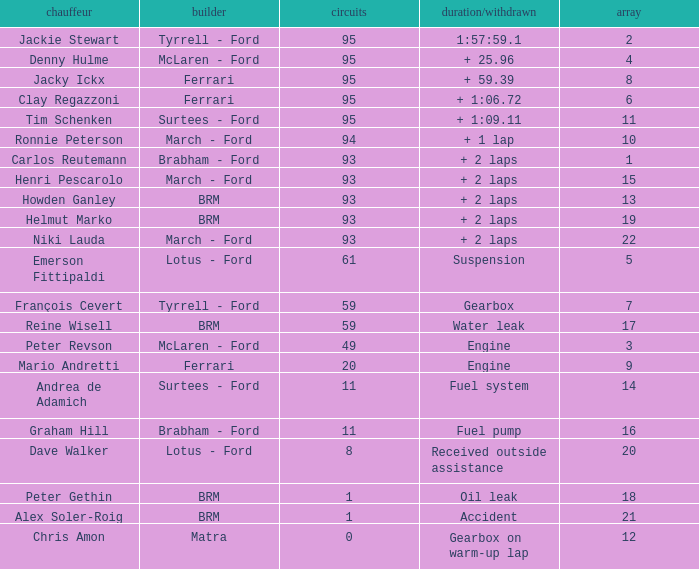Which grid has less than 11 laps, and a Time/Retired of accident? 21.0. 